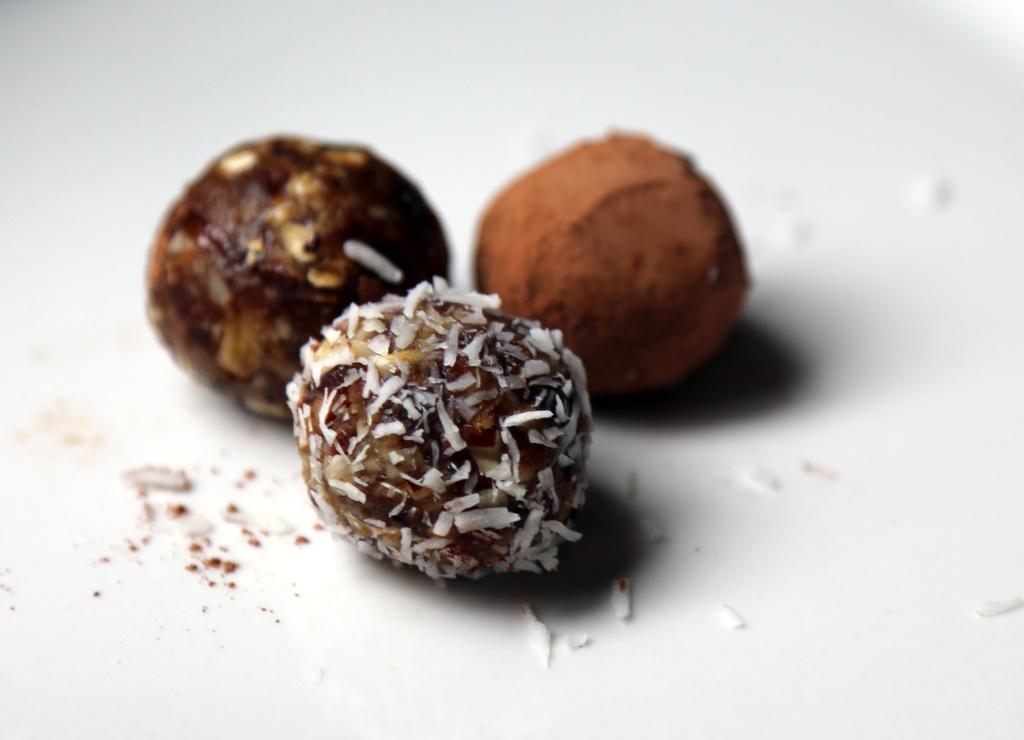In one or two sentences, can you explain what this image depicts? In this image we can see food on the white object. 